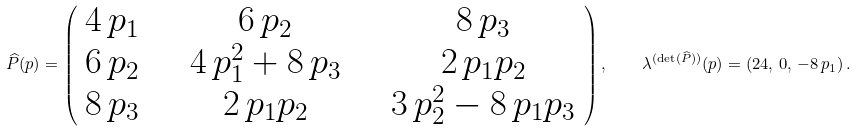<formula> <loc_0><loc_0><loc_500><loc_500>\widehat { P } ( p ) = \left ( \begin{array} { c c c } 4 \, p _ { 1 } & \quad 6 \, p _ { 2 } & \quad 8 \, p _ { 3 } \\ 6 \, p _ { 2 } & \quad 4 \, p _ { 1 } ^ { 2 } + 8 \, p _ { 3 } & \quad 2 \, p _ { 1 } p _ { 2 } \\ 8 \, p _ { 3 } & \quad 2 \, p _ { 1 } p _ { 2 } & \quad 3 \, p _ { 2 } ^ { 2 } - 8 \, p _ { 1 } p _ { 3 } \\ \end{array} \right ) , \quad \lambda ^ { ( \det ( \widehat { P } ) ) } ( p ) = ( 2 4 , \, 0 , \, - 8 \, p _ { 1 } ) \, .</formula> 